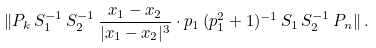<formula> <loc_0><loc_0><loc_500><loc_500>\| P _ { k } \, S _ { 1 } ^ { - 1 } \, S _ { 2 } ^ { - 1 } \, \frac { x _ { 1 } - x _ { 2 } } { | x _ { 1 } - x _ { 2 } | ^ { 3 } } \cdot p _ { 1 } \, ( p _ { 1 } ^ { 2 } + 1 ) ^ { - 1 } \, S _ { 1 } \, S _ { 2 } ^ { - 1 } \, P _ { n } \| \, .</formula> 